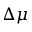<formula> <loc_0><loc_0><loc_500><loc_500>\Delta \mu</formula> 